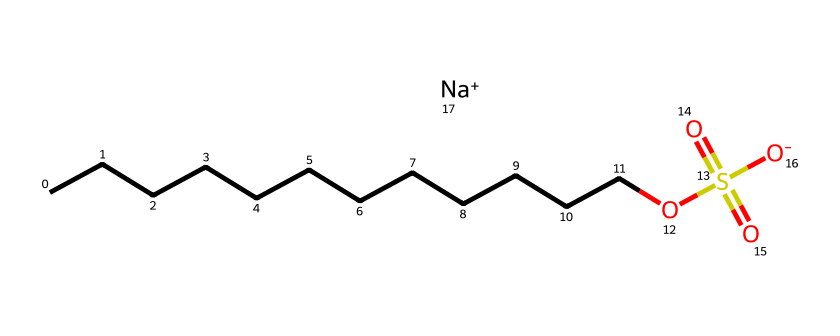How many carbon atoms are present in the chemical structure? The chemical has a carbon chain represented by "CCCCCCCCCCCC", which indicates there are 12 carbon atoms in total.
Answer: 12 What type of functional group is present in this chemical? The structure contains the notation "OS(=O)(=O)", which indicates the presence of a sulfonate functional group.
Answer: sulfonate What does the presence of sodium ion suggest about this chemical? The notation "[Na+]" indicates that this chemical is sodium salt of the sulfonate compound, which often enhances its solubility in water.
Answer: sodium salt How does the structure of this detergent contribute to its ability to remove organic matter? The long hydrocarbon chain ("CCCCCCCCCCCC") provides hydrophobic properties, while the sulfonate group enhances hydrophilic interactions, allowing it to interact with both organic matter and water effectively.
Answer: hydrophobic and hydrophilic interactions Which part of the chemical structure is responsible for its surface-active properties? The long chain of carbon atoms provides hydrophobic characteristics, while the sulfonate group contributes hydrophilic characteristics, a balance that allows the detergent to reduce surface tension and exhibit surface-active properties.
Answer: hydrocarbon chain and sulfonate group 